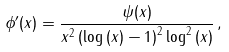Convert formula to latex. <formula><loc_0><loc_0><loc_500><loc_500>\phi ^ { \prime } ( x ) = \frac { \psi ( x ) } { x ^ { 2 } \left ( \log \left ( x \right ) - 1 \right ) ^ { 2 } \log ^ { 2 } \left ( x \right ) } \, ,</formula> 